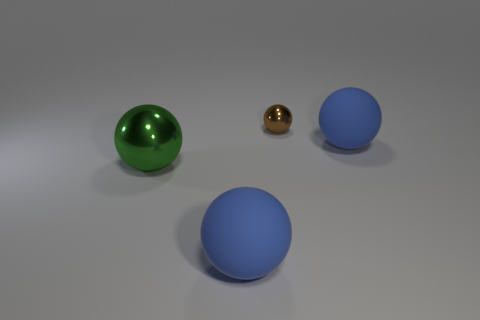What is the shape of the metallic object that is in front of the big sphere that is on the right side of the tiny brown object? The metallic object in front of the large sphere, positioned to the right of the small brown object, is spherical in shape. This metallic sphere appears to have a reflective gold-colored surface, contrasting with the matte textures of the other objects. 